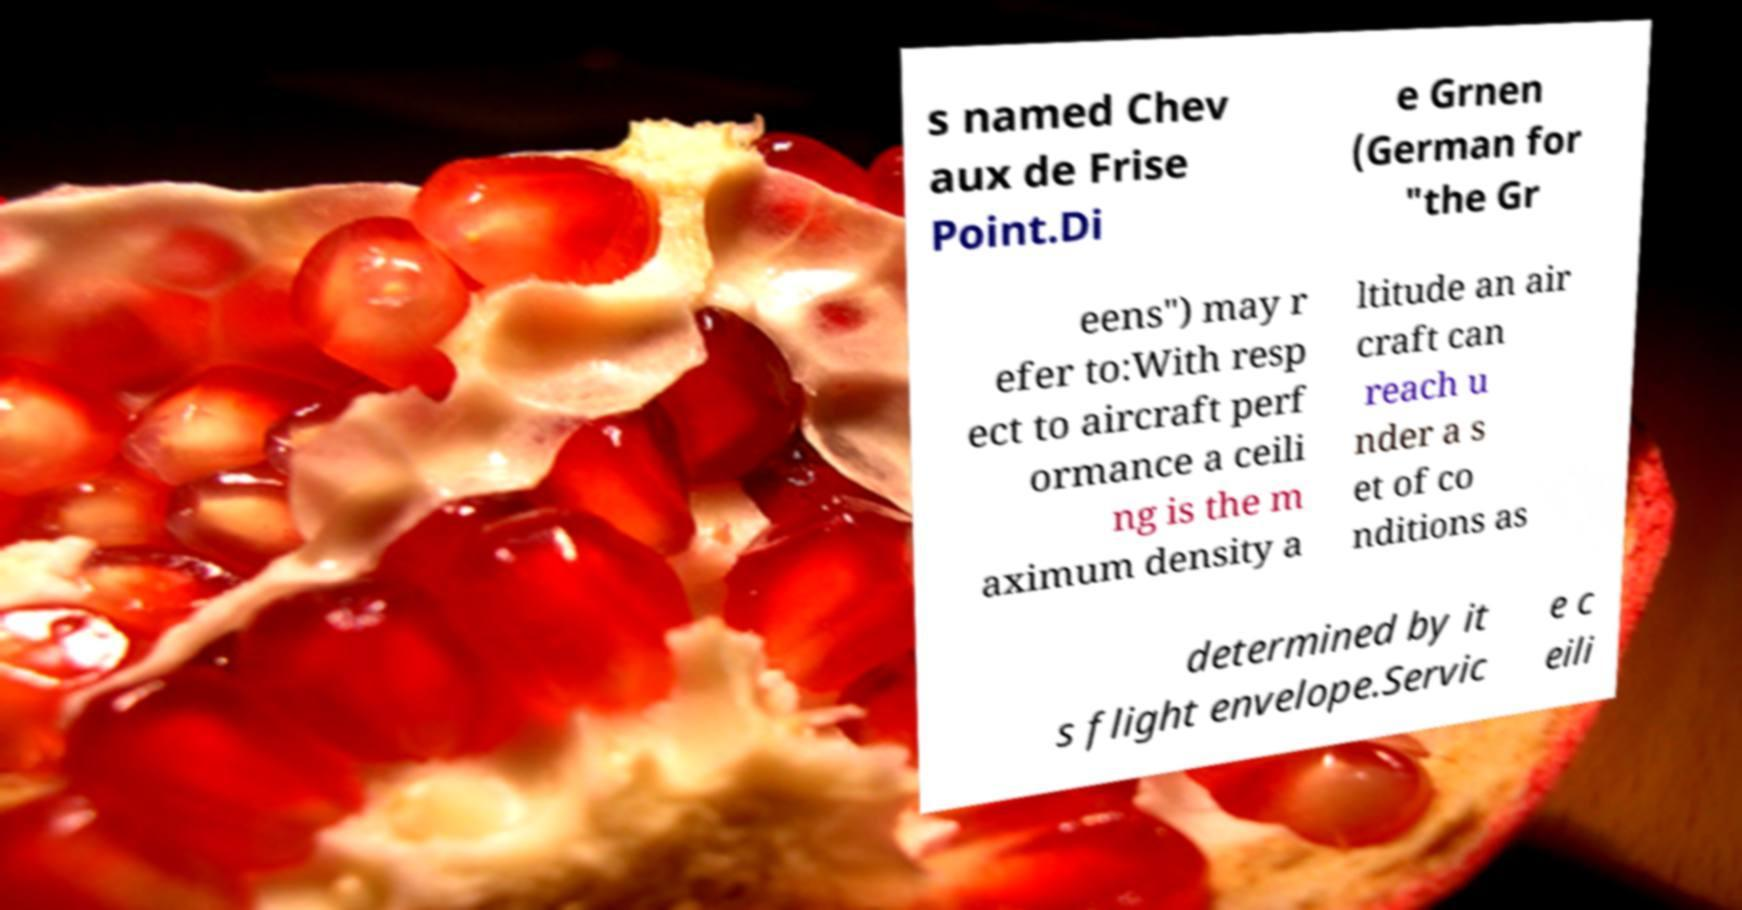For documentation purposes, I need the text within this image transcribed. Could you provide that? s named Chev aux de Frise Point.Di e Grnen (German for "the Gr eens") may r efer to:With resp ect to aircraft perf ormance a ceili ng is the m aximum density a ltitude an air craft can reach u nder a s et of co nditions as determined by it s flight envelope.Servic e c eili 